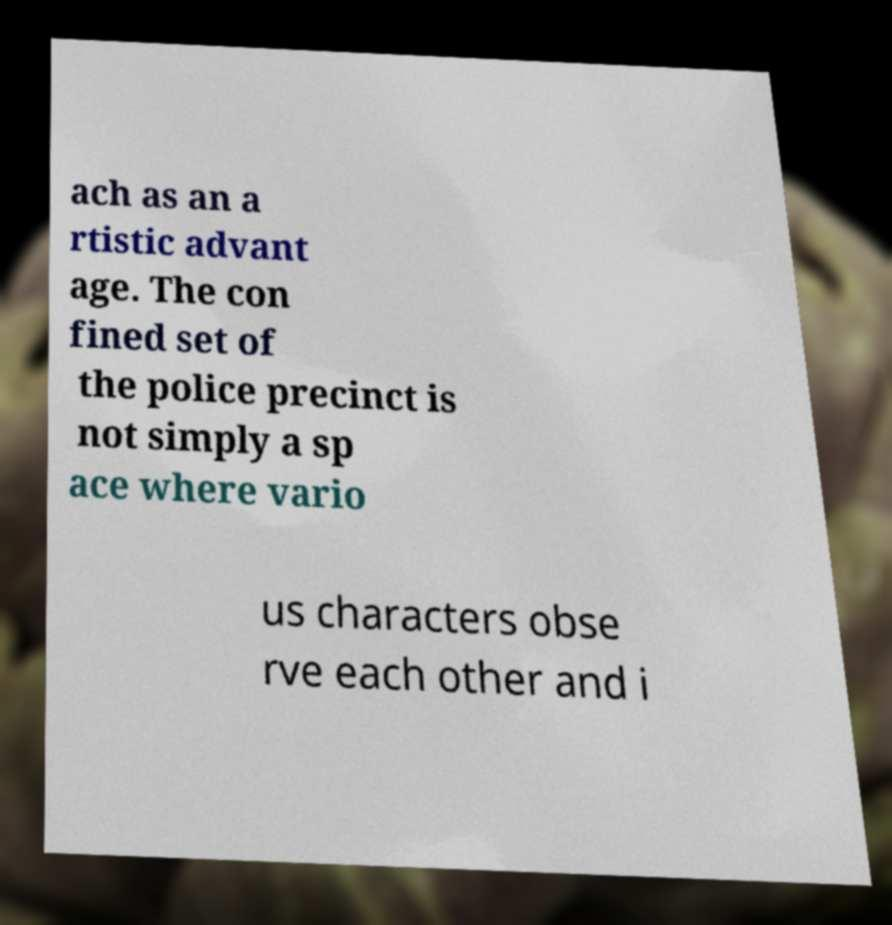Please read and relay the text visible in this image. What does it say? ach as an a rtistic advant age. The con fined set of the police precinct is not simply a sp ace where vario us characters obse rve each other and i 